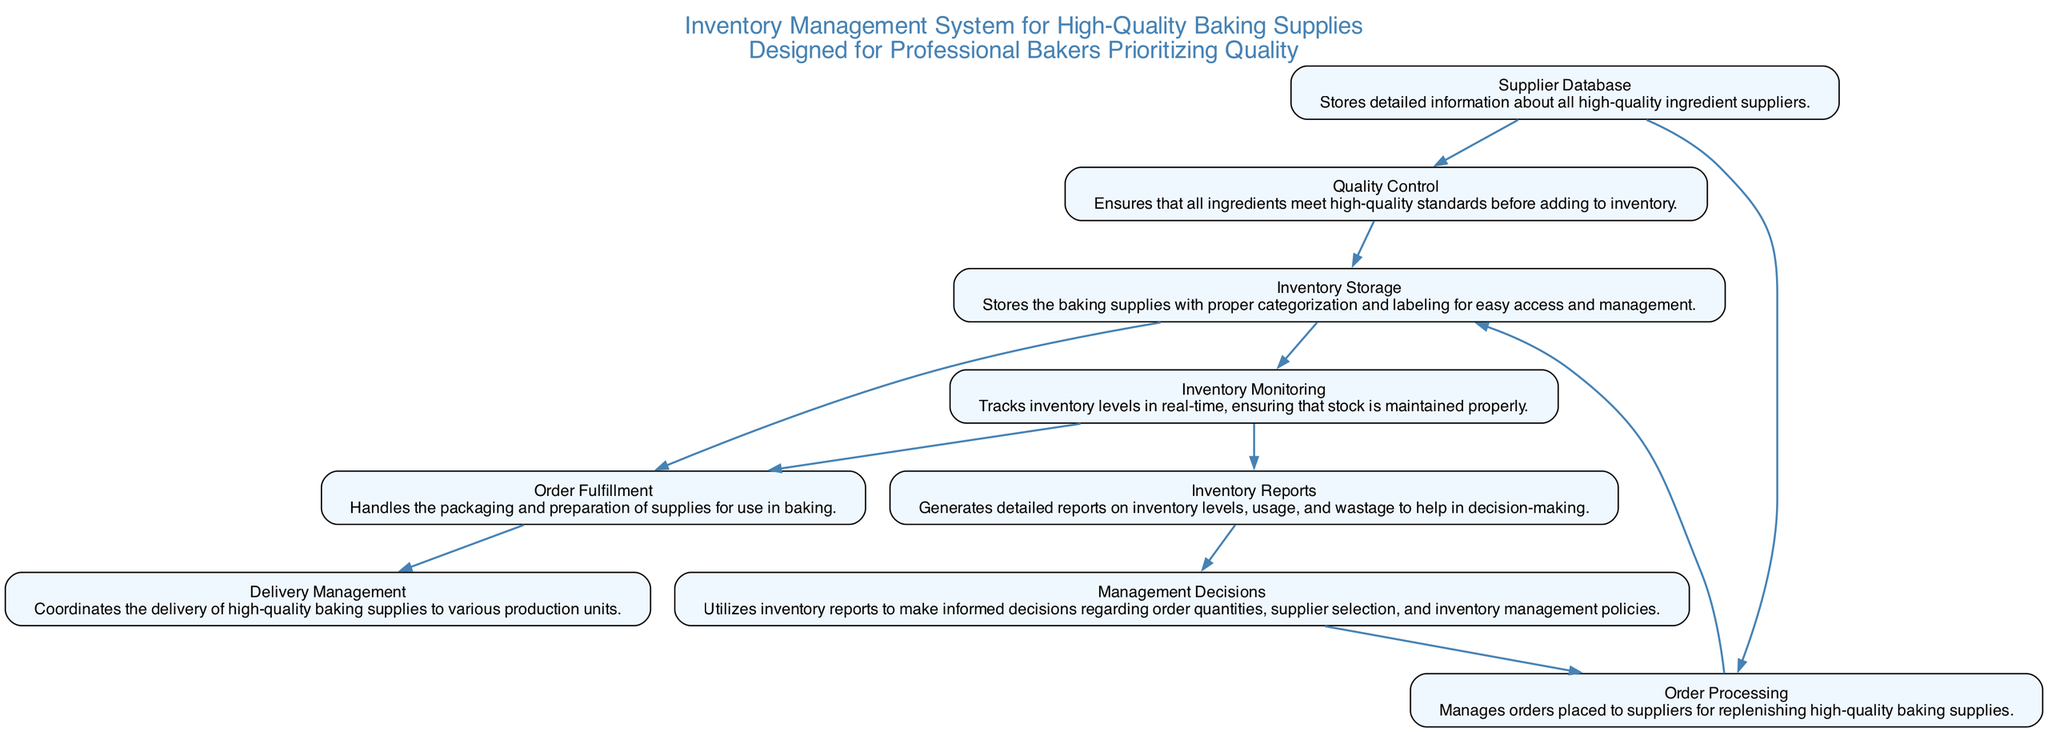What is the first element in the diagram? The diagram starts with the "Supplier Database" node, which is the first element listed in the inventory management system.
Answer: Supplier Database How many output relationships does the "Quality Control" element have? The "Quality Control" element has one output relationship that leads to the "Inventory Storage" element.
Answer: 1 Which element is directly connected to "Inventory Monitoring"? "Inventory Storage" is directly connected to "Inventory Monitoring" as its output, making it the preceding element.
Answer: Inventory Storage What is the last element in the flow of the diagram? The last element in this block diagram is "Delivery Management," which doesn't have any outputs of its own, indicating it is the final step.
Answer: Delivery Management How many elements are there in total within this diagram? The diagram contains eight distinct elements that represent different components of the inventory management system.
Answer: 8 What does the "Order Processing" element output? The "Order Processing" element outputs to the "Inventory Storage" element, indicating that it manages orders to refill supplies.
Answer: Inventory Storage Which element informs "Management Decisions"? The "Inventory Reports" element is the one that provides information for "Management Decisions," helping in the decision-making process.
Answer: Inventory Reports What are the two outputs of "Inventory Storage"? The "Inventory Storage" element has two outputs: "Inventory Monitoring" and "Order Fulfillment," which are essential for managing stock and orders.
Answer: Inventory Monitoring, Order Fulfillment How does "Quality Control" contribute to the inventory system? "Quality Control" ensures that all ingredients meet high-quality standards, which is vital before adding to "Inventory Storage."
Answer: Ensures high-quality standards 